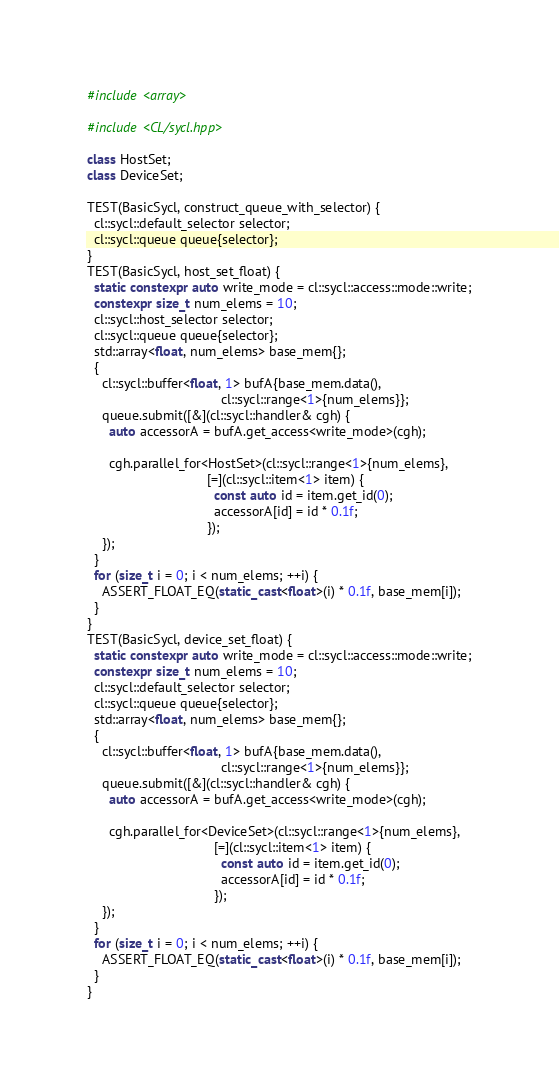Convert code to text. <code><loc_0><loc_0><loc_500><loc_500><_C++_>#include <array>

#include <CL/sycl.hpp>

class HostSet;
class DeviceSet;

TEST(BasicSycl, construct_queue_with_selector) {
  cl::sycl::default_selector selector;
  cl::sycl::queue queue{selector};
}
TEST(BasicSycl, host_set_float) {
  static constexpr auto write_mode = cl::sycl::access::mode::write;
  constexpr size_t num_elems = 10;
  cl::sycl::host_selector selector;
  cl::sycl::queue queue{selector};
  std::array<float, num_elems> base_mem{};
  {
    cl::sycl::buffer<float, 1> bufA{base_mem.data(),
                                    cl::sycl::range<1>{num_elems}};
    queue.submit([&](cl::sycl::handler& cgh) {
      auto accessorA = bufA.get_access<write_mode>(cgh);

      cgh.parallel_for<HostSet>(cl::sycl::range<1>{num_elems},
                                [=](cl::sycl::item<1> item) {
                                  const auto id = item.get_id(0);
                                  accessorA[id] = id * 0.1f;
                                });
    });
  }
  for (size_t i = 0; i < num_elems; ++i) {
    ASSERT_FLOAT_EQ(static_cast<float>(i) * 0.1f, base_mem[i]);
  }
}
TEST(BasicSycl, device_set_float) {
  static constexpr auto write_mode = cl::sycl::access::mode::write;
  constexpr size_t num_elems = 10;
  cl::sycl::default_selector selector;
  cl::sycl::queue queue{selector};
  std::array<float, num_elems> base_mem{};
  {
    cl::sycl::buffer<float, 1> bufA{base_mem.data(),
                                    cl::sycl::range<1>{num_elems}};
    queue.submit([&](cl::sycl::handler& cgh) {
      auto accessorA = bufA.get_access<write_mode>(cgh);

      cgh.parallel_for<DeviceSet>(cl::sycl::range<1>{num_elems},
                                  [=](cl::sycl::item<1> item) {
                                    const auto id = item.get_id(0);
                                    accessorA[id] = id * 0.1f;
                                  });
    });
  }
  for (size_t i = 0; i < num_elems; ++i) {
    ASSERT_FLOAT_EQ(static_cast<float>(i) * 0.1f, base_mem[i]);
  }
}
</code> 